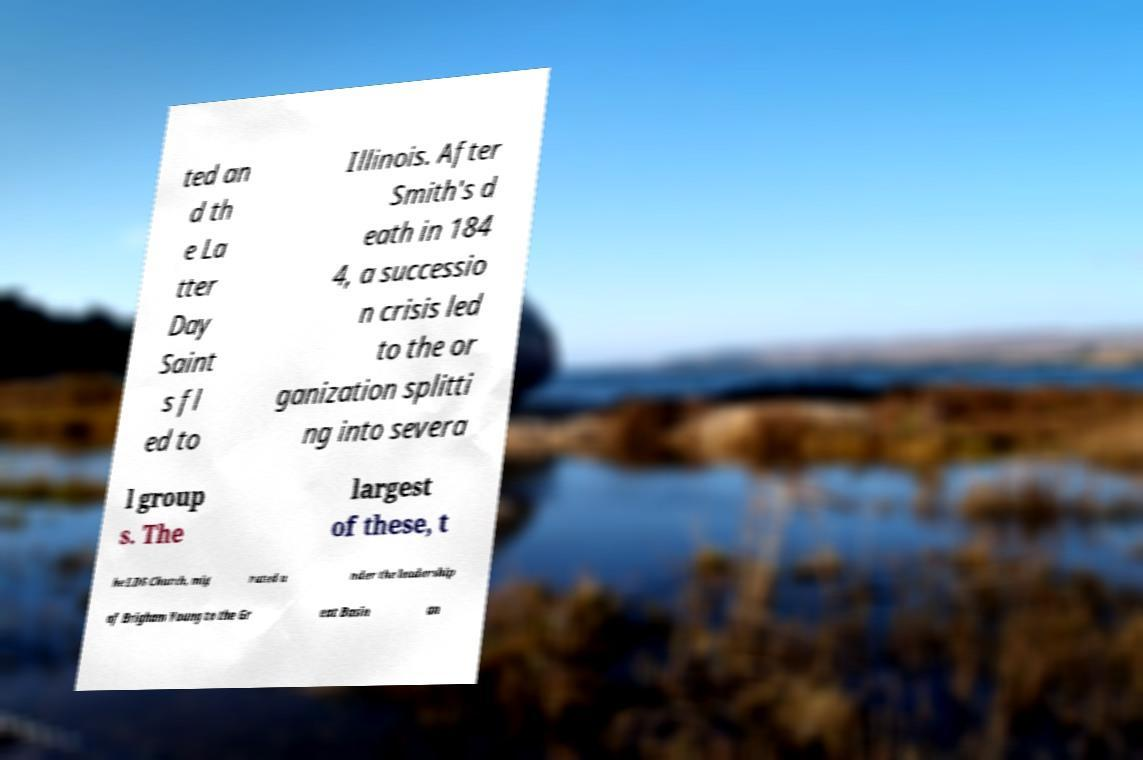What messages or text are displayed in this image? I need them in a readable, typed format. ted an d th e La tter Day Saint s fl ed to Illinois. After Smith's d eath in 184 4, a successio n crisis led to the or ganization splitti ng into severa l group s. The largest of these, t he LDS Church, mig rated u nder the leadership of Brigham Young to the Gr eat Basin an 